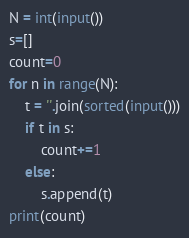<code> <loc_0><loc_0><loc_500><loc_500><_Python_>N = int(input())
s=[]
count=0
for n in range(N):
    t = ''.join(sorted(input()))
    if t in s:
        count+=1
    else:
        s.append(t)
print(count)</code> 